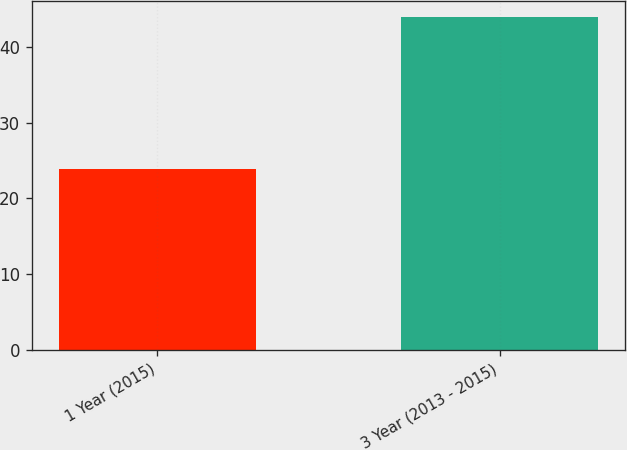<chart> <loc_0><loc_0><loc_500><loc_500><bar_chart><fcel>1 Year (2015)<fcel>3 Year (2013 - 2015)<nl><fcel>23.9<fcel>43.9<nl></chart> 